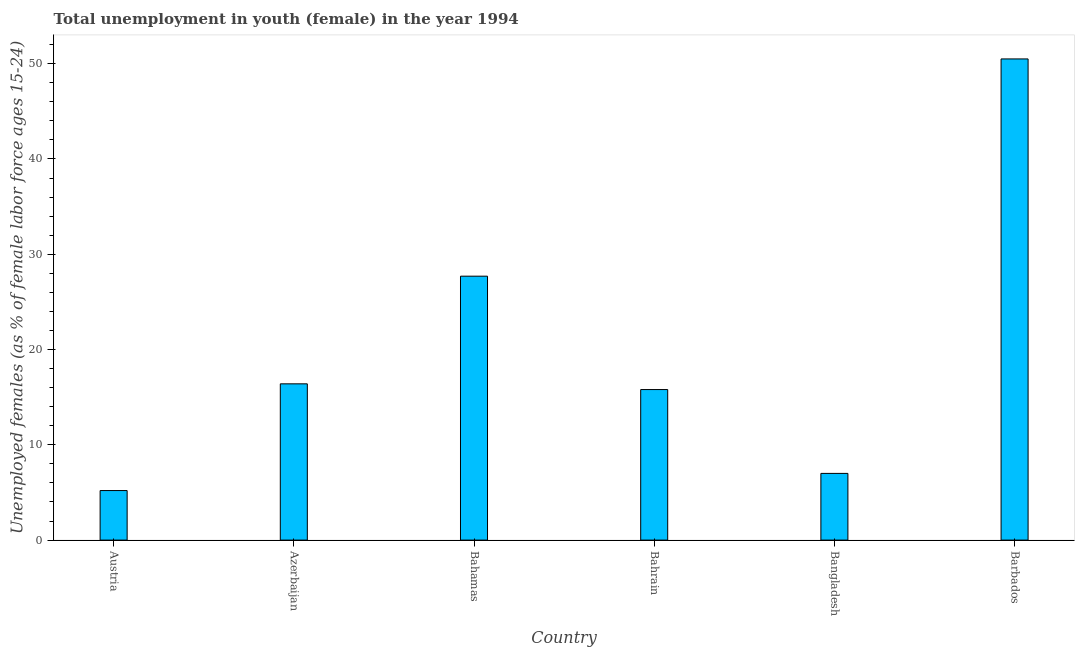Does the graph contain grids?
Offer a terse response. No. What is the title of the graph?
Offer a very short reply. Total unemployment in youth (female) in the year 1994. What is the label or title of the X-axis?
Ensure brevity in your answer.  Country. What is the label or title of the Y-axis?
Offer a terse response. Unemployed females (as % of female labor force ages 15-24). What is the unemployed female youth population in Azerbaijan?
Offer a terse response. 16.4. Across all countries, what is the maximum unemployed female youth population?
Make the answer very short. 50.5. Across all countries, what is the minimum unemployed female youth population?
Your response must be concise. 5.2. In which country was the unemployed female youth population maximum?
Offer a very short reply. Barbados. In which country was the unemployed female youth population minimum?
Give a very brief answer. Austria. What is the sum of the unemployed female youth population?
Make the answer very short. 122.6. What is the average unemployed female youth population per country?
Ensure brevity in your answer.  20.43. What is the median unemployed female youth population?
Your answer should be compact. 16.1. What is the ratio of the unemployed female youth population in Azerbaijan to that in Bahamas?
Your answer should be compact. 0.59. Is the unemployed female youth population in Bahrain less than that in Bangladesh?
Make the answer very short. No. Is the difference between the unemployed female youth population in Bangladesh and Barbados greater than the difference between any two countries?
Ensure brevity in your answer.  No. What is the difference between the highest and the second highest unemployed female youth population?
Keep it short and to the point. 22.8. Is the sum of the unemployed female youth population in Bahamas and Barbados greater than the maximum unemployed female youth population across all countries?
Your response must be concise. Yes. What is the difference between the highest and the lowest unemployed female youth population?
Your answer should be compact. 45.3. Are all the bars in the graph horizontal?
Make the answer very short. No. How many countries are there in the graph?
Provide a short and direct response. 6. What is the difference between two consecutive major ticks on the Y-axis?
Offer a very short reply. 10. What is the Unemployed females (as % of female labor force ages 15-24) in Austria?
Keep it short and to the point. 5.2. What is the Unemployed females (as % of female labor force ages 15-24) in Azerbaijan?
Keep it short and to the point. 16.4. What is the Unemployed females (as % of female labor force ages 15-24) in Bahamas?
Make the answer very short. 27.7. What is the Unemployed females (as % of female labor force ages 15-24) in Bahrain?
Provide a short and direct response. 15.8. What is the Unemployed females (as % of female labor force ages 15-24) of Barbados?
Provide a succinct answer. 50.5. What is the difference between the Unemployed females (as % of female labor force ages 15-24) in Austria and Azerbaijan?
Your answer should be very brief. -11.2. What is the difference between the Unemployed females (as % of female labor force ages 15-24) in Austria and Bahamas?
Make the answer very short. -22.5. What is the difference between the Unemployed females (as % of female labor force ages 15-24) in Austria and Bahrain?
Your answer should be very brief. -10.6. What is the difference between the Unemployed females (as % of female labor force ages 15-24) in Austria and Barbados?
Give a very brief answer. -45.3. What is the difference between the Unemployed females (as % of female labor force ages 15-24) in Azerbaijan and Bahamas?
Offer a terse response. -11.3. What is the difference between the Unemployed females (as % of female labor force ages 15-24) in Azerbaijan and Bangladesh?
Your answer should be very brief. 9.4. What is the difference between the Unemployed females (as % of female labor force ages 15-24) in Azerbaijan and Barbados?
Your response must be concise. -34.1. What is the difference between the Unemployed females (as % of female labor force ages 15-24) in Bahamas and Bahrain?
Your answer should be very brief. 11.9. What is the difference between the Unemployed females (as % of female labor force ages 15-24) in Bahamas and Bangladesh?
Offer a terse response. 20.7. What is the difference between the Unemployed females (as % of female labor force ages 15-24) in Bahamas and Barbados?
Your answer should be very brief. -22.8. What is the difference between the Unemployed females (as % of female labor force ages 15-24) in Bahrain and Barbados?
Offer a terse response. -34.7. What is the difference between the Unemployed females (as % of female labor force ages 15-24) in Bangladesh and Barbados?
Provide a short and direct response. -43.5. What is the ratio of the Unemployed females (as % of female labor force ages 15-24) in Austria to that in Azerbaijan?
Provide a succinct answer. 0.32. What is the ratio of the Unemployed females (as % of female labor force ages 15-24) in Austria to that in Bahamas?
Provide a succinct answer. 0.19. What is the ratio of the Unemployed females (as % of female labor force ages 15-24) in Austria to that in Bahrain?
Your answer should be compact. 0.33. What is the ratio of the Unemployed females (as % of female labor force ages 15-24) in Austria to that in Bangladesh?
Ensure brevity in your answer.  0.74. What is the ratio of the Unemployed females (as % of female labor force ages 15-24) in Austria to that in Barbados?
Your answer should be compact. 0.1. What is the ratio of the Unemployed females (as % of female labor force ages 15-24) in Azerbaijan to that in Bahamas?
Keep it short and to the point. 0.59. What is the ratio of the Unemployed females (as % of female labor force ages 15-24) in Azerbaijan to that in Bahrain?
Make the answer very short. 1.04. What is the ratio of the Unemployed females (as % of female labor force ages 15-24) in Azerbaijan to that in Bangladesh?
Make the answer very short. 2.34. What is the ratio of the Unemployed females (as % of female labor force ages 15-24) in Azerbaijan to that in Barbados?
Offer a very short reply. 0.33. What is the ratio of the Unemployed females (as % of female labor force ages 15-24) in Bahamas to that in Bahrain?
Ensure brevity in your answer.  1.75. What is the ratio of the Unemployed females (as % of female labor force ages 15-24) in Bahamas to that in Bangladesh?
Give a very brief answer. 3.96. What is the ratio of the Unemployed females (as % of female labor force ages 15-24) in Bahamas to that in Barbados?
Keep it short and to the point. 0.55. What is the ratio of the Unemployed females (as % of female labor force ages 15-24) in Bahrain to that in Bangladesh?
Provide a short and direct response. 2.26. What is the ratio of the Unemployed females (as % of female labor force ages 15-24) in Bahrain to that in Barbados?
Keep it short and to the point. 0.31. What is the ratio of the Unemployed females (as % of female labor force ages 15-24) in Bangladesh to that in Barbados?
Provide a short and direct response. 0.14. 